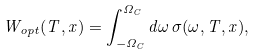Convert formula to latex. <formula><loc_0><loc_0><loc_500><loc_500>W _ { o p t } ( T , x ) = \int _ { - \Omega _ { C } } ^ { \Omega _ { C } } d \omega \, \sigma ( \omega , T , x ) ,</formula> 